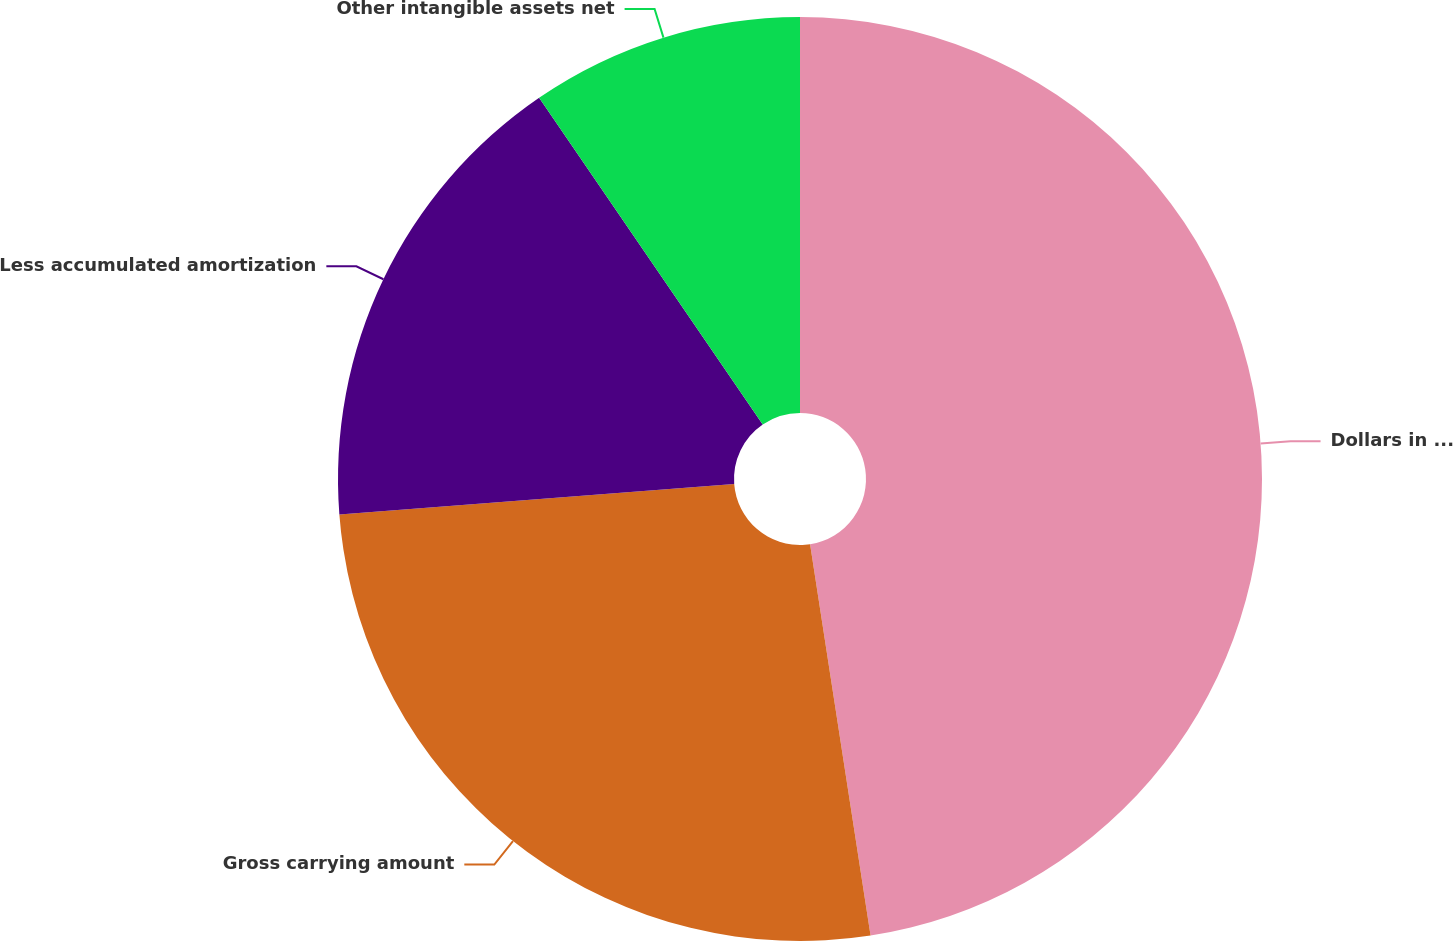Convert chart to OTSL. <chart><loc_0><loc_0><loc_500><loc_500><pie_chart><fcel>Dollars in Millions<fcel>Gross carrying amount<fcel>Less accumulated amortization<fcel>Other intangible assets net<nl><fcel>47.56%<fcel>26.22%<fcel>16.67%<fcel>9.55%<nl></chart> 